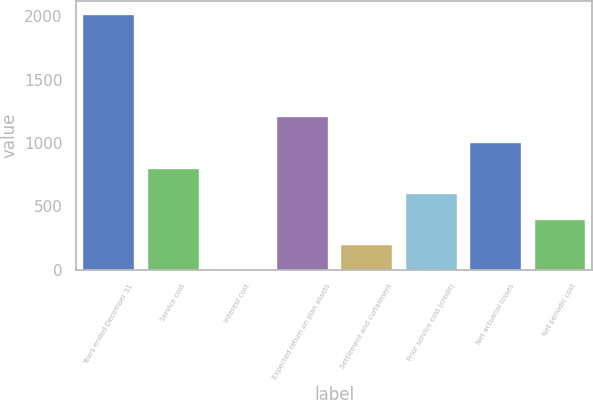<chart> <loc_0><loc_0><loc_500><loc_500><bar_chart><fcel>Years ended December 31<fcel>Service cost<fcel>Interest cost<fcel>Expected return on plan assets<fcel>Settlement and curtailment<fcel>Prior service cost (credit)<fcel>Net actuarial losses<fcel>Net periodic cost<nl><fcel>2015<fcel>806.18<fcel>0.3<fcel>1209.12<fcel>201.77<fcel>604.71<fcel>1007.65<fcel>403.24<nl></chart> 